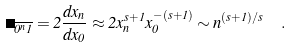<formula> <loc_0><loc_0><loc_500><loc_500>\Lambda _ { \overline { 0 ^ { n } 1 } } = 2 \frac { d x _ { n } } { d x _ { 0 } } \approx 2 x _ { n } ^ { s + 1 } x _ { 0 } ^ { - ( s + 1 ) } \sim n ^ { ( s + 1 ) / s } \ \ .</formula> 